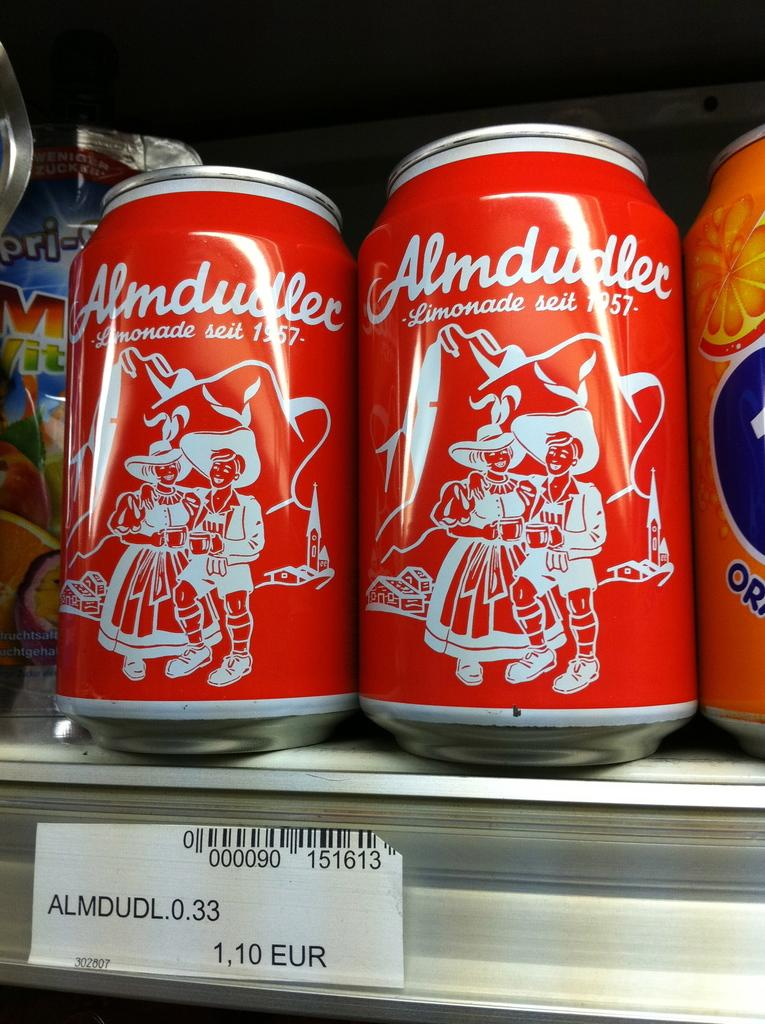<image>
Summarize the visual content of the image. The two cans of Limonade seit 1957 on a shelf are from the brand Almdudlec. 